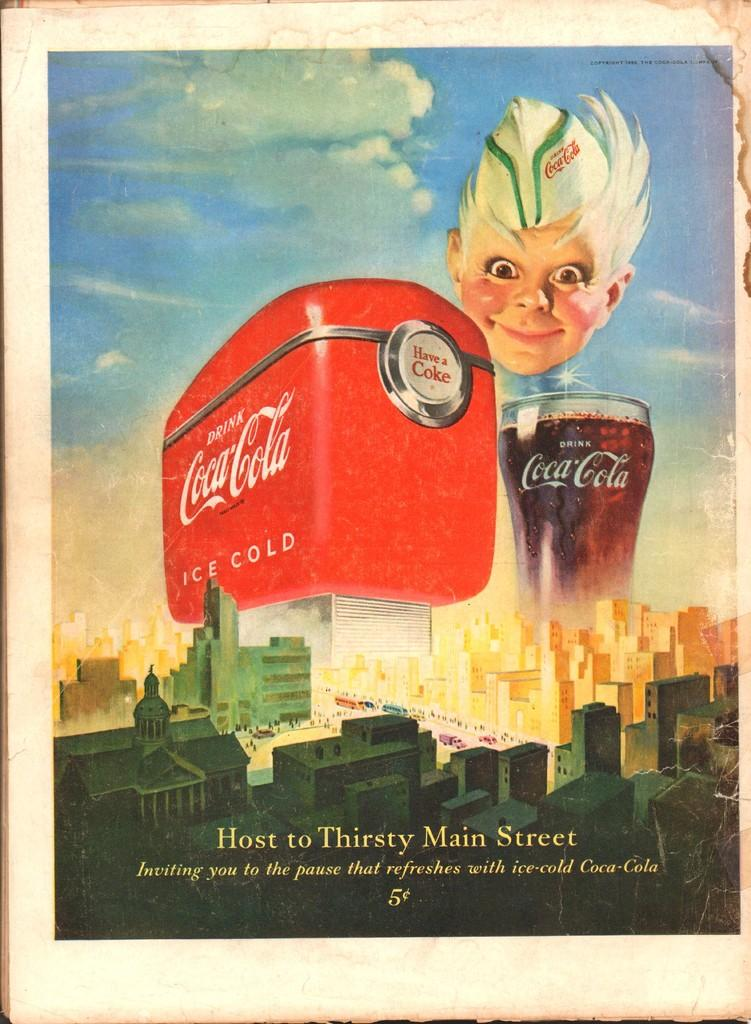What is featured on the poster in the image? The facts do not specify what is on the poster, so we cannot answer this question definitively. What type of structures can be seen in the image? There are buildings in the image. Can you describe the person in the image? The facts do not specify any details about the person, so we cannot answer this question definitively. What is visible in the background of the image? The sky is visible in the image. What other objects are present in the image besides the poster and buildings? The facts mention that there are objects in the image, but do not specify what they are. Is there any text present in the image? Yes, there is text in the image. How many pigs are visible in the image? There are no pigs present in the image. 